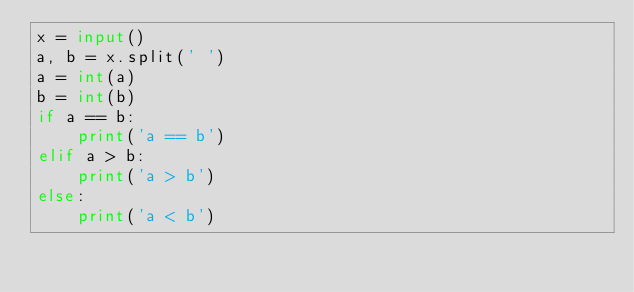Convert code to text. <code><loc_0><loc_0><loc_500><loc_500><_Python_>x = input()
a, b = x.split(' ')
a = int(a)
b = int(b)
if a == b:
    print('a == b')
elif a > b:
    print('a > b')
else:
    print('a < b')
</code> 